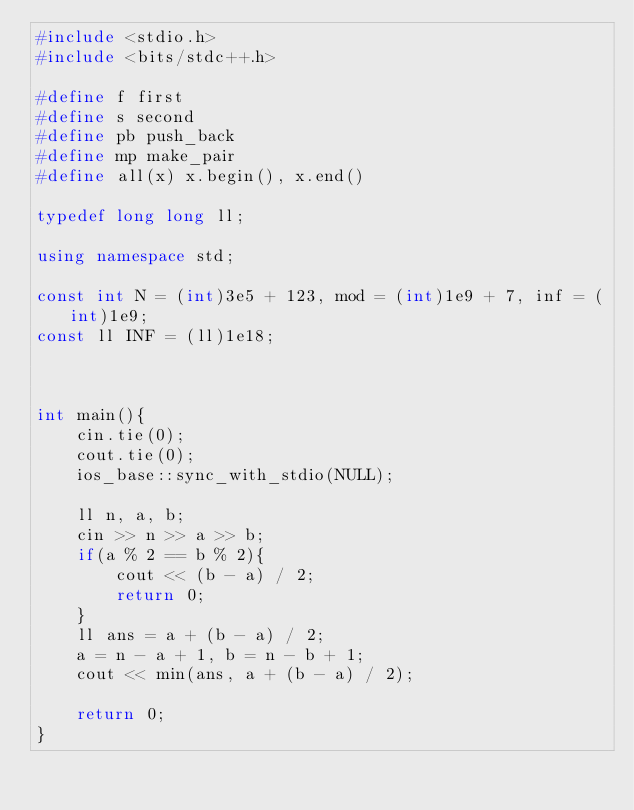<code> <loc_0><loc_0><loc_500><loc_500><_C++_>#include <stdio.h>
#include <bits/stdc++.h>

#define f first
#define s second
#define pb push_back
#define mp make_pair
#define all(x) x.begin(), x.end()

typedef long long ll;

using namespace std;

const int N = (int)3e5 + 123, mod = (int)1e9 + 7, inf = (int)1e9;
const ll INF = (ll)1e18;



int main(){
	cin.tie(0);
	cout.tie(0);
	ios_base::sync_with_stdio(NULL);

	ll n, a, b;
	cin >> n >> a >> b;
	if(a % 2 == b % 2){
		cout << (b - a) / 2;
		return 0;
	}
	ll ans = a + (b - a) / 2;
	a = n - a + 1, b = n - b + 1;
	cout << min(ans, a + (b - a) / 2);

	return 0;
}</code> 